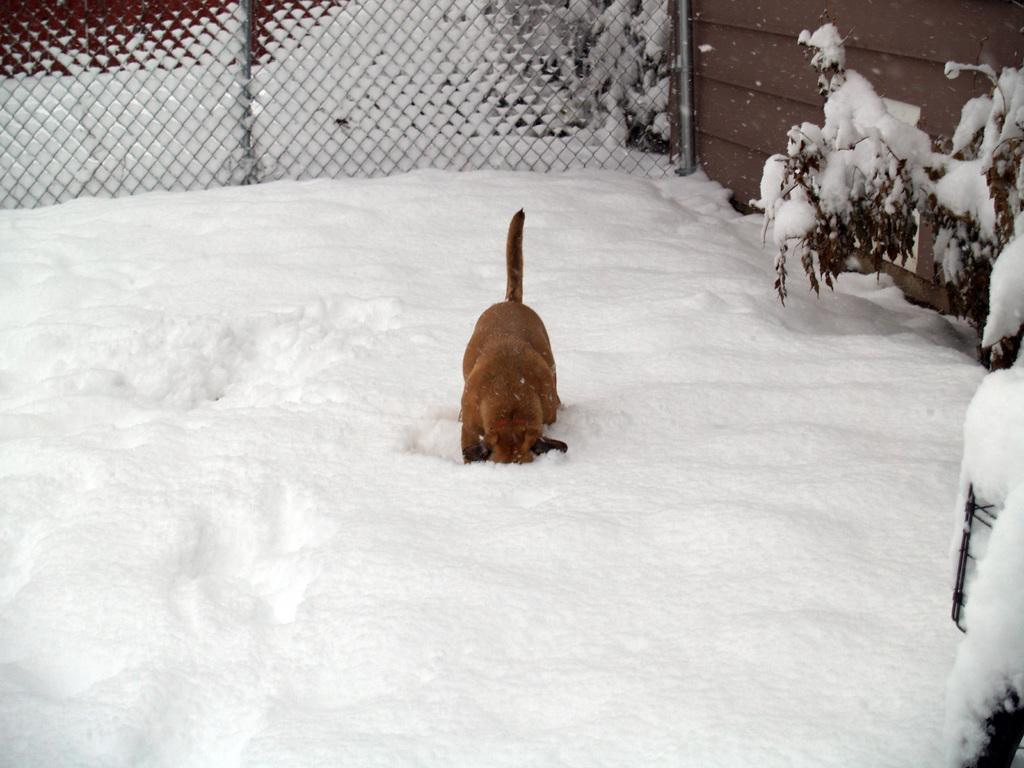What is the main subject of the image? There is a dog in the center of the image. What is the dog standing on? The dog is on the snow. What can be seen in the background of the image? There is fencing and a house in the background of the image. What type of vase can be seen in the image? There is no vase present in the image; it features a dog on the snow with a background of fencing and a house. 